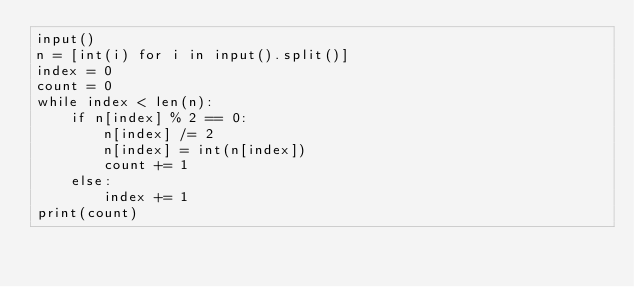<code> <loc_0><loc_0><loc_500><loc_500><_Python_>input()
n = [int(i) for i in input().split()]
index = 0
count = 0
while index < len(n):
    if n[index] % 2 == 0:
        n[index] /= 2
        n[index] = int(n[index])
        count += 1
    else:
        index += 1
print(count)
</code> 